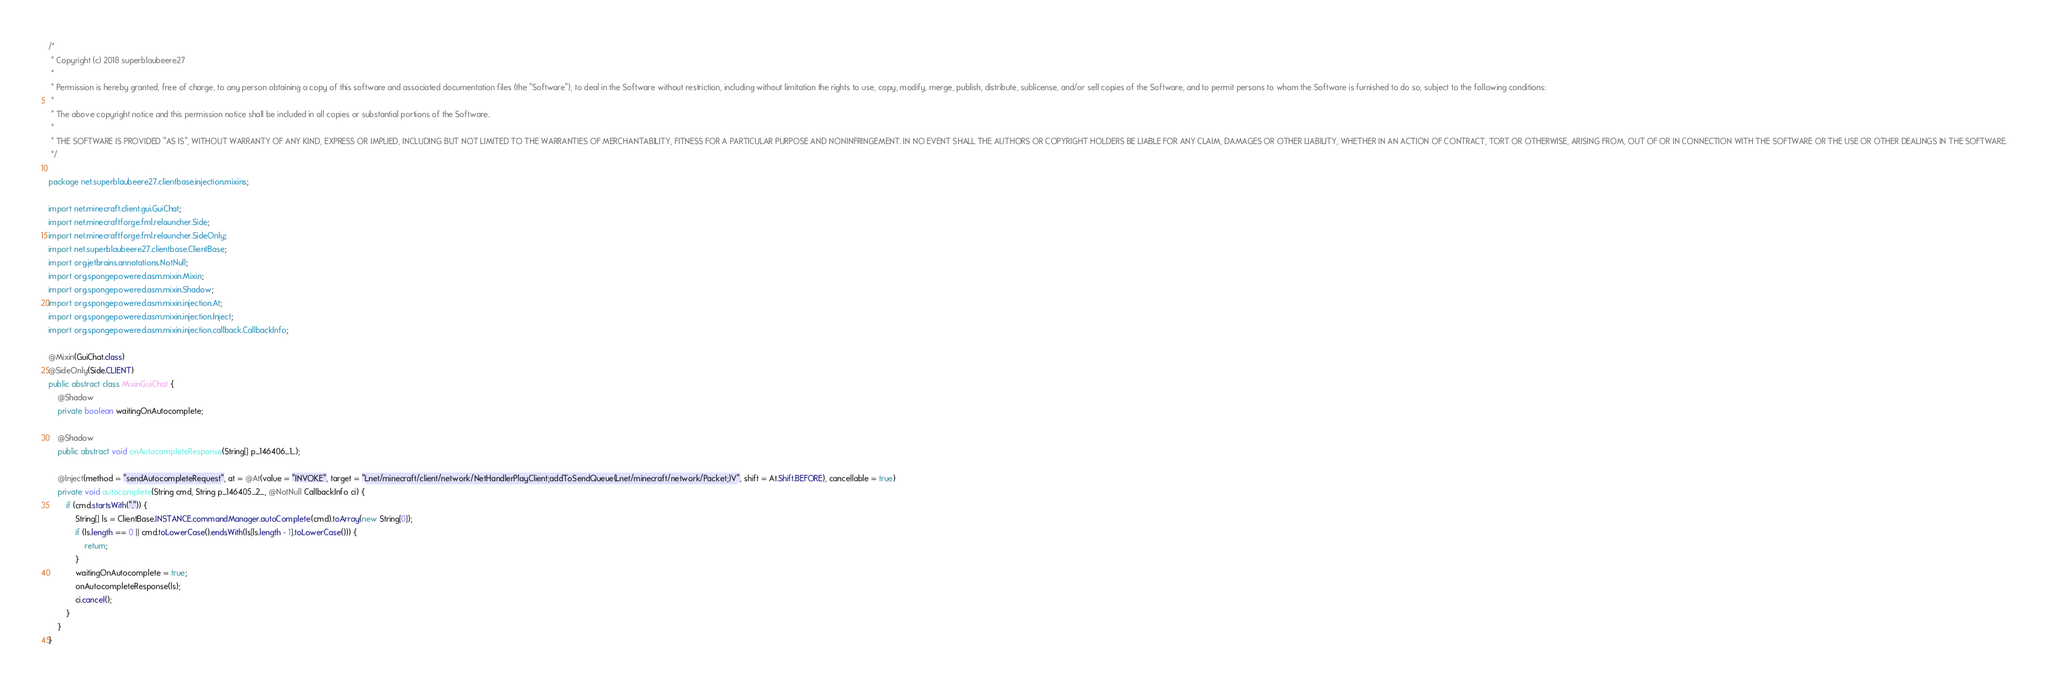<code> <loc_0><loc_0><loc_500><loc_500><_Java_>/*
 * Copyright (c) 2018 superblaubeere27
 *
 * Permission is hereby granted, free of charge, to any person obtaining a copy of this software and associated documentation files (the "Software"), to deal in the Software without restriction, including without limitation the rights to use, copy, modify, merge, publish, distribute, sublicense, and/or sell copies of the Software, and to permit persons to whom the Software is furnished to do so, subject to the following conditions:
 *
 * The above copyright notice and this permission notice shall be included in all copies or substantial portions of the Software.
 *
 * THE SOFTWARE IS PROVIDED "AS IS", WITHOUT WARRANTY OF ANY KIND, EXPRESS OR IMPLIED, INCLUDING BUT NOT LIMITED TO THE WARRANTIES OF MERCHANTABILITY, FITNESS FOR A PARTICULAR PURPOSE AND NONINFRINGEMENT. IN NO EVENT SHALL THE AUTHORS OR COPYRIGHT HOLDERS BE LIABLE FOR ANY CLAIM, DAMAGES OR OTHER LIABILITY, WHETHER IN AN ACTION OF CONTRACT, TORT OR OTHERWISE, ARISING FROM, OUT OF OR IN CONNECTION WITH THE SOFTWARE OR THE USE OR OTHER DEALINGS IN THE SOFTWARE.
 */

package net.superblaubeere27.clientbase.injection.mixins;

import net.minecraft.client.gui.GuiChat;
import net.minecraftforge.fml.relauncher.Side;
import net.minecraftforge.fml.relauncher.SideOnly;
import net.superblaubeere27.clientbase.ClientBase;
import org.jetbrains.annotations.NotNull;
import org.spongepowered.asm.mixin.Mixin;
import org.spongepowered.asm.mixin.Shadow;
import org.spongepowered.asm.mixin.injection.At;
import org.spongepowered.asm.mixin.injection.Inject;
import org.spongepowered.asm.mixin.injection.callback.CallbackInfo;

@Mixin(GuiChat.class)
@SideOnly(Side.CLIENT)
public abstract class MixinGuiChat {
    @Shadow
    private boolean waitingOnAutocomplete;

    @Shadow
    public abstract void onAutocompleteResponse(String[] p_146406_1_);

    @Inject(method = "sendAutocompleteRequest", at = @At(value = "INVOKE", target = "Lnet/minecraft/client/network/NetHandlerPlayClient;addToSendQueue(Lnet/minecraft/network/Packet;)V", shift = At.Shift.BEFORE), cancellable = true)
    private void autocomplete(String cmd, String p_146405_2_, @NotNull CallbackInfo ci) {
        if (cmd.startsWith(".")) {
            String[] ls = ClientBase.INSTANCE.commandManager.autoComplete(cmd).toArray(new String[0]);
            if (ls.length == 0 || cmd.toLowerCase().endsWith(ls[ls.length - 1].toLowerCase())) {
                return;
            }
            waitingOnAutocomplete = true;
            onAutocompleteResponse(ls);
            ci.cancel();
        }
    }
}
</code> 